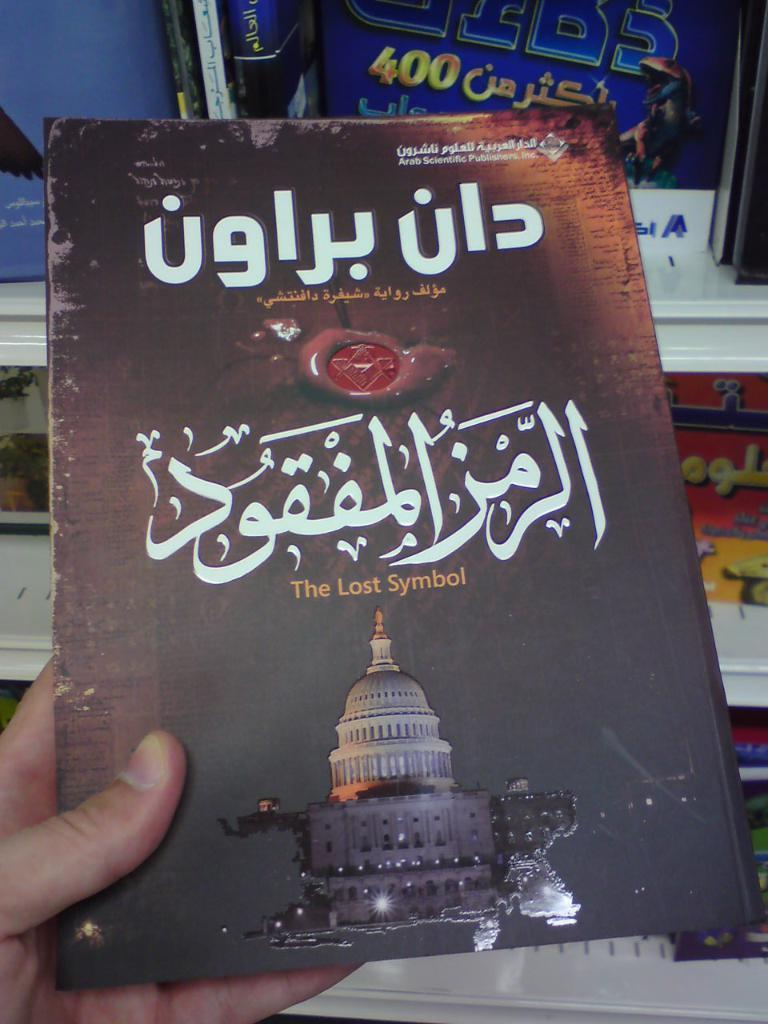<image>
Present a compact description of the photo's key features. A foreign language item that reads The Last Symbol in English. 